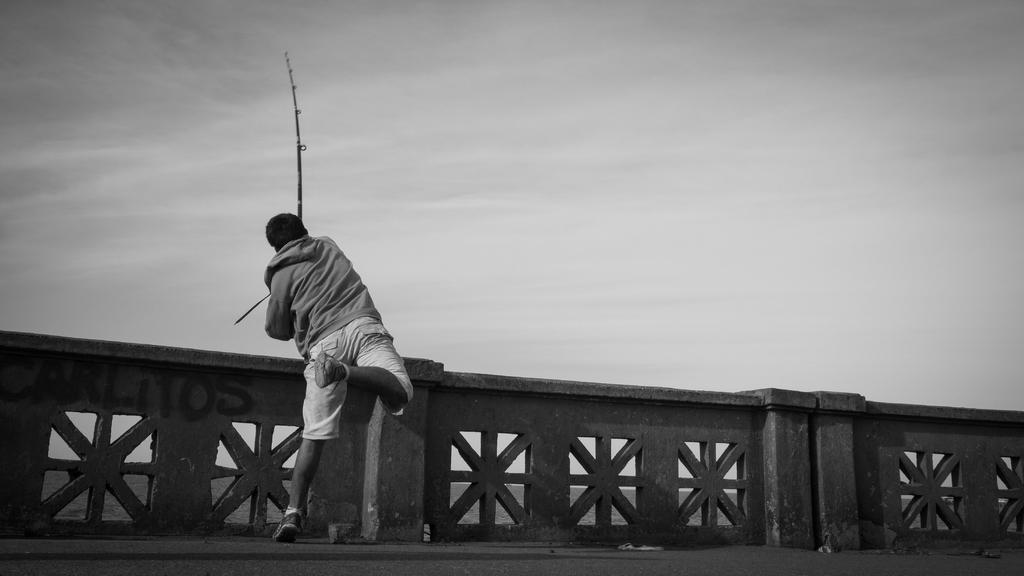How would you summarize this image in a sentence or two? In this image I can see the black and white picture of a person who is holding a caperlan which is black in color in his hand. I can see the concrete railing. In the background I can see the water and the sky. 